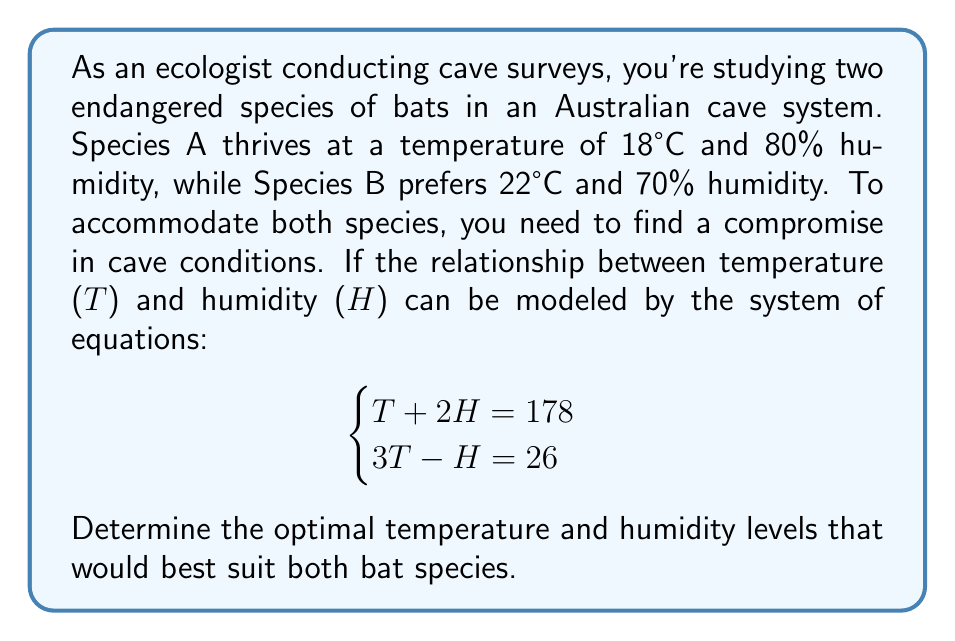Teach me how to tackle this problem. To solve this system of equations, we'll use the substitution method:

1) From the first equation, express T in terms of H:
   $$T + 2H = 178$$
   $$T = 178 - 2H$$

2) Substitute this expression for T into the second equation:
   $$3(178 - 2H) - H = 26$$

3) Simplify:
   $$534 - 6H - H = 26$$
   $$534 - 7H = 26$$

4) Solve for H:
   $$-7H = -508$$
   $$H = \frac{508}{7} \approx 72.57$$

5) Substitute this H value back into the equation from step 1 to find T:
   $$T = 178 - 2(72.57)$$
   $$T = 178 - 145.14 = 32.86$$

6) Round to one decimal place:
   $$T \approx 20.0°C$$
   $$H \approx 72.6\%$$

These values represent a compromise between the preferred conditions of both species:
- Temperature: between 18°C (Species A) and 22°C (Species B)
- Humidity: between 70% (Species B) and 80% (Species A)
Answer: The optimal cave conditions for both bat species are approximately 20.0°C and 72.6% humidity. 